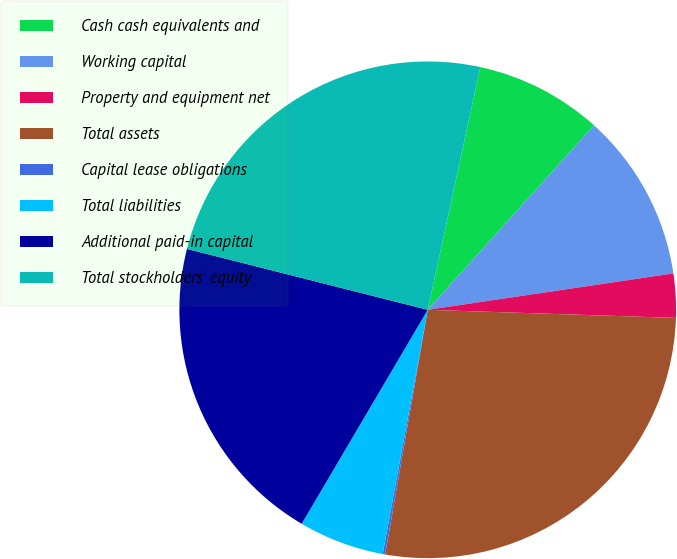Convert chart to OTSL. <chart><loc_0><loc_0><loc_500><loc_500><pie_chart><fcel>Cash cash equivalents and<fcel>Working capital<fcel>Property and equipment net<fcel>Total assets<fcel>Capital lease obligations<fcel>Total liabilities<fcel>Additional paid-in capital<fcel>Total stockholders' equity<nl><fcel>8.28%<fcel>10.98%<fcel>2.86%<fcel>27.22%<fcel>0.16%<fcel>5.57%<fcel>20.47%<fcel>24.45%<nl></chart> 